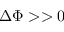<formula> <loc_0><loc_0><loc_500><loc_500>\Delta \Phi > > 0</formula> 